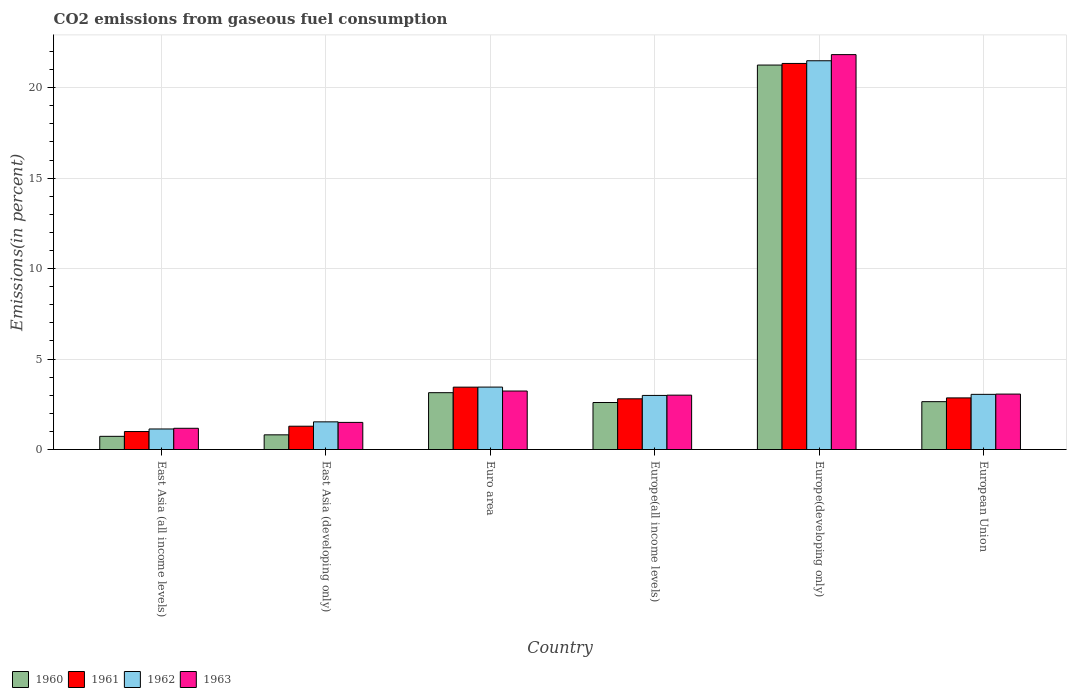Are the number of bars per tick equal to the number of legend labels?
Your response must be concise. Yes. Are the number of bars on each tick of the X-axis equal?
Give a very brief answer. Yes. How many bars are there on the 5th tick from the left?
Give a very brief answer. 4. What is the label of the 1st group of bars from the left?
Your response must be concise. East Asia (all income levels). What is the total CO2 emitted in 1960 in Euro area?
Keep it short and to the point. 3.14. Across all countries, what is the maximum total CO2 emitted in 1961?
Provide a short and direct response. 21.34. Across all countries, what is the minimum total CO2 emitted in 1963?
Make the answer very short. 1.17. In which country was the total CO2 emitted in 1961 maximum?
Keep it short and to the point. Europe(developing only). In which country was the total CO2 emitted in 1963 minimum?
Give a very brief answer. East Asia (all income levels). What is the total total CO2 emitted in 1961 in the graph?
Offer a very short reply. 32.73. What is the difference between the total CO2 emitted in 1961 in East Asia (all income levels) and that in Euro area?
Your answer should be compact. -2.45. What is the difference between the total CO2 emitted in 1961 in Europe(all income levels) and the total CO2 emitted in 1963 in Europe(developing only)?
Offer a very short reply. -19.03. What is the average total CO2 emitted in 1962 per country?
Your response must be concise. 5.61. What is the difference between the total CO2 emitted of/in 1960 and total CO2 emitted of/in 1963 in East Asia (all income levels)?
Ensure brevity in your answer.  -0.45. What is the ratio of the total CO2 emitted in 1961 in East Asia (all income levels) to that in European Union?
Give a very brief answer. 0.35. Is the difference between the total CO2 emitted in 1960 in East Asia (developing only) and Europe(developing only) greater than the difference between the total CO2 emitted in 1963 in East Asia (developing only) and Europe(developing only)?
Your answer should be very brief. No. What is the difference between the highest and the second highest total CO2 emitted in 1963?
Provide a short and direct response. -0.17. What is the difference between the highest and the lowest total CO2 emitted in 1962?
Your answer should be very brief. 20.35. Is the sum of the total CO2 emitted in 1963 in East Asia (all income levels) and Europe(developing only) greater than the maximum total CO2 emitted in 1962 across all countries?
Make the answer very short. Yes. What does the 4th bar from the right in Europe(developing only) represents?
Keep it short and to the point. 1960. Is it the case that in every country, the sum of the total CO2 emitted in 1960 and total CO2 emitted in 1962 is greater than the total CO2 emitted in 1963?
Your response must be concise. Yes. How many bars are there?
Give a very brief answer. 24. How many countries are there in the graph?
Give a very brief answer. 6. How are the legend labels stacked?
Your answer should be very brief. Horizontal. What is the title of the graph?
Offer a terse response. CO2 emissions from gaseous fuel consumption. Does "1975" appear as one of the legend labels in the graph?
Provide a succinct answer. No. What is the label or title of the X-axis?
Offer a terse response. Country. What is the label or title of the Y-axis?
Provide a short and direct response. Emissions(in percent). What is the Emissions(in percent) of 1960 in East Asia (all income levels)?
Offer a terse response. 0.73. What is the Emissions(in percent) in 1961 in East Asia (all income levels)?
Provide a short and direct response. 0.99. What is the Emissions(in percent) in 1962 in East Asia (all income levels)?
Your answer should be compact. 1.14. What is the Emissions(in percent) of 1963 in East Asia (all income levels)?
Ensure brevity in your answer.  1.17. What is the Emissions(in percent) in 1960 in East Asia (developing only)?
Keep it short and to the point. 0.81. What is the Emissions(in percent) of 1961 in East Asia (developing only)?
Keep it short and to the point. 1.29. What is the Emissions(in percent) in 1962 in East Asia (developing only)?
Offer a very short reply. 1.53. What is the Emissions(in percent) in 1963 in East Asia (developing only)?
Your answer should be very brief. 1.5. What is the Emissions(in percent) of 1960 in Euro area?
Your answer should be compact. 3.14. What is the Emissions(in percent) of 1961 in Euro area?
Your answer should be compact. 3.45. What is the Emissions(in percent) of 1962 in Euro area?
Offer a terse response. 3.45. What is the Emissions(in percent) in 1963 in Euro area?
Keep it short and to the point. 3.23. What is the Emissions(in percent) of 1960 in Europe(all income levels)?
Provide a succinct answer. 2.6. What is the Emissions(in percent) of 1961 in Europe(all income levels)?
Provide a short and direct response. 2.8. What is the Emissions(in percent) of 1962 in Europe(all income levels)?
Keep it short and to the point. 2.99. What is the Emissions(in percent) in 1963 in Europe(all income levels)?
Ensure brevity in your answer.  3.01. What is the Emissions(in percent) of 1960 in Europe(developing only)?
Your response must be concise. 21.25. What is the Emissions(in percent) in 1961 in Europe(developing only)?
Ensure brevity in your answer.  21.34. What is the Emissions(in percent) of 1962 in Europe(developing only)?
Ensure brevity in your answer.  21.49. What is the Emissions(in percent) of 1963 in Europe(developing only)?
Provide a short and direct response. 21.83. What is the Emissions(in percent) in 1960 in European Union?
Make the answer very short. 2.65. What is the Emissions(in percent) of 1961 in European Union?
Your answer should be very brief. 2.85. What is the Emissions(in percent) in 1962 in European Union?
Your response must be concise. 3.05. What is the Emissions(in percent) of 1963 in European Union?
Keep it short and to the point. 3.06. Across all countries, what is the maximum Emissions(in percent) of 1960?
Your answer should be very brief. 21.25. Across all countries, what is the maximum Emissions(in percent) in 1961?
Give a very brief answer. 21.34. Across all countries, what is the maximum Emissions(in percent) in 1962?
Ensure brevity in your answer.  21.49. Across all countries, what is the maximum Emissions(in percent) in 1963?
Offer a very short reply. 21.83. Across all countries, what is the minimum Emissions(in percent) of 1960?
Your answer should be compact. 0.73. Across all countries, what is the minimum Emissions(in percent) of 1961?
Your response must be concise. 0.99. Across all countries, what is the minimum Emissions(in percent) of 1962?
Your answer should be very brief. 1.14. Across all countries, what is the minimum Emissions(in percent) of 1963?
Your answer should be compact. 1.17. What is the total Emissions(in percent) of 1960 in the graph?
Offer a very short reply. 31.18. What is the total Emissions(in percent) of 1961 in the graph?
Make the answer very short. 32.73. What is the total Emissions(in percent) of 1962 in the graph?
Make the answer very short. 33.65. What is the total Emissions(in percent) of 1963 in the graph?
Your response must be concise. 33.81. What is the difference between the Emissions(in percent) in 1960 in East Asia (all income levels) and that in East Asia (developing only)?
Your answer should be compact. -0.08. What is the difference between the Emissions(in percent) of 1961 in East Asia (all income levels) and that in East Asia (developing only)?
Offer a very short reply. -0.29. What is the difference between the Emissions(in percent) in 1962 in East Asia (all income levels) and that in East Asia (developing only)?
Offer a terse response. -0.39. What is the difference between the Emissions(in percent) in 1963 in East Asia (all income levels) and that in East Asia (developing only)?
Keep it short and to the point. -0.33. What is the difference between the Emissions(in percent) in 1960 in East Asia (all income levels) and that in Euro area?
Your response must be concise. -2.41. What is the difference between the Emissions(in percent) in 1961 in East Asia (all income levels) and that in Euro area?
Provide a short and direct response. -2.45. What is the difference between the Emissions(in percent) in 1962 in East Asia (all income levels) and that in Euro area?
Provide a succinct answer. -2.32. What is the difference between the Emissions(in percent) of 1963 in East Asia (all income levels) and that in Euro area?
Keep it short and to the point. -2.06. What is the difference between the Emissions(in percent) in 1960 in East Asia (all income levels) and that in Europe(all income levels)?
Your response must be concise. -1.87. What is the difference between the Emissions(in percent) of 1961 in East Asia (all income levels) and that in Europe(all income levels)?
Make the answer very short. -1.81. What is the difference between the Emissions(in percent) of 1962 in East Asia (all income levels) and that in Europe(all income levels)?
Your answer should be very brief. -1.85. What is the difference between the Emissions(in percent) in 1963 in East Asia (all income levels) and that in Europe(all income levels)?
Provide a short and direct response. -1.83. What is the difference between the Emissions(in percent) of 1960 in East Asia (all income levels) and that in Europe(developing only)?
Make the answer very short. -20.52. What is the difference between the Emissions(in percent) of 1961 in East Asia (all income levels) and that in Europe(developing only)?
Your answer should be compact. -20.35. What is the difference between the Emissions(in percent) of 1962 in East Asia (all income levels) and that in Europe(developing only)?
Keep it short and to the point. -20.35. What is the difference between the Emissions(in percent) of 1963 in East Asia (all income levels) and that in Europe(developing only)?
Provide a succinct answer. -20.66. What is the difference between the Emissions(in percent) of 1960 in East Asia (all income levels) and that in European Union?
Give a very brief answer. -1.92. What is the difference between the Emissions(in percent) of 1961 in East Asia (all income levels) and that in European Union?
Ensure brevity in your answer.  -1.86. What is the difference between the Emissions(in percent) in 1962 in East Asia (all income levels) and that in European Union?
Your answer should be very brief. -1.91. What is the difference between the Emissions(in percent) in 1963 in East Asia (all income levels) and that in European Union?
Your response must be concise. -1.89. What is the difference between the Emissions(in percent) in 1960 in East Asia (developing only) and that in Euro area?
Offer a terse response. -2.33. What is the difference between the Emissions(in percent) of 1961 in East Asia (developing only) and that in Euro area?
Offer a very short reply. -2.16. What is the difference between the Emissions(in percent) in 1962 in East Asia (developing only) and that in Euro area?
Your response must be concise. -1.92. What is the difference between the Emissions(in percent) of 1963 in East Asia (developing only) and that in Euro area?
Keep it short and to the point. -1.73. What is the difference between the Emissions(in percent) of 1960 in East Asia (developing only) and that in Europe(all income levels)?
Your answer should be very brief. -1.79. What is the difference between the Emissions(in percent) in 1961 in East Asia (developing only) and that in Europe(all income levels)?
Offer a very short reply. -1.51. What is the difference between the Emissions(in percent) of 1962 in East Asia (developing only) and that in Europe(all income levels)?
Your answer should be compact. -1.46. What is the difference between the Emissions(in percent) in 1963 in East Asia (developing only) and that in Europe(all income levels)?
Ensure brevity in your answer.  -1.51. What is the difference between the Emissions(in percent) in 1960 in East Asia (developing only) and that in Europe(developing only)?
Offer a very short reply. -20.44. What is the difference between the Emissions(in percent) in 1961 in East Asia (developing only) and that in Europe(developing only)?
Make the answer very short. -20.05. What is the difference between the Emissions(in percent) of 1962 in East Asia (developing only) and that in Europe(developing only)?
Ensure brevity in your answer.  -19.96. What is the difference between the Emissions(in percent) of 1963 in East Asia (developing only) and that in Europe(developing only)?
Offer a very short reply. -20.33. What is the difference between the Emissions(in percent) of 1960 in East Asia (developing only) and that in European Union?
Provide a short and direct response. -1.83. What is the difference between the Emissions(in percent) of 1961 in East Asia (developing only) and that in European Union?
Provide a short and direct response. -1.56. What is the difference between the Emissions(in percent) in 1962 in East Asia (developing only) and that in European Union?
Ensure brevity in your answer.  -1.52. What is the difference between the Emissions(in percent) in 1963 in East Asia (developing only) and that in European Union?
Give a very brief answer. -1.57. What is the difference between the Emissions(in percent) in 1960 in Euro area and that in Europe(all income levels)?
Your answer should be compact. 0.54. What is the difference between the Emissions(in percent) of 1961 in Euro area and that in Europe(all income levels)?
Give a very brief answer. 0.64. What is the difference between the Emissions(in percent) of 1962 in Euro area and that in Europe(all income levels)?
Your answer should be compact. 0.46. What is the difference between the Emissions(in percent) of 1963 in Euro area and that in Europe(all income levels)?
Provide a succinct answer. 0.23. What is the difference between the Emissions(in percent) of 1960 in Euro area and that in Europe(developing only)?
Give a very brief answer. -18.11. What is the difference between the Emissions(in percent) in 1961 in Euro area and that in Europe(developing only)?
Ensure brevity in your answer.  -17.89. What is the difference between the Emissions(in percent) of 1962 in Euro area and that in Europe(developing only)?
Offer a terse response. -18.04. What is the difference between the Emissions(in percent) of 1963 in Euro area and that in Europe(developing only)?
Keep it short and to the point. -18.6. What is the difference between the Emissions(in percent) of 1960 in Euro area and that in European Union?
Make the answer very short. 0.5. What is the difference between the Emissions(in percent) of 1961 in Euro area and that in European Union?
Give a very brief answer. 0.59. What is the difference between the Emissions(in percent) of 1962 in Euro area and that in European Union?
Your answer should be very brief. 0.4. What is the difference between the Emissions(in percent) of 1963 in Euro area and that in European Union?
Give a very brief answer. 0.17. What is the difference between the Emissions(in percent) of 1960 in Europe(all income levels) and that in Europe(developing only)?
Provide a short and direct response. -18.65. What is the difference between the Emissions(in percent) in 1961 in Europe(all income levels) and that in Europe(developing only)?
Offer a very short reply. -18.54. What is the difference between the Emissions(in percent) in 1962 in Europe(all income levels) and that in Europe(developing only)?
Offer a terse response. -18.5. What is the difference between the Emissions(in percent) in 1963 in Europe(all income levels) and that in Europe(developing only)?
Make the answer very short. -18.82. What is the difference between the Emissions(in percent) of 1960 in Europe(all income levels) and that in European Union?
Offer a terse response. -0.05. What is the difference between the Emissions(in percent) of 1961 in Europe(all income levels) and that in European Union?
Your answer should be compact. -0.05. What is the difference between the Emissions(in percent) in 1962 in Europe(all income levels) and that in European Union?
Keep it short and to the point. -0.06. What is the difference between the Emissions(in percent) of 1963 in Europe(all income levels) and that in European Union?
Offer a terse response. -0.06. What is the difference between the Emissions(in percent) of 1960 in Europe(developing only) and that in European Union?
Provide a short and direct response. 18.61. What is the difference between the Emissions(in percent) in 1961 in Europe(developing only) and that in European Union?
Ensure brevity in your answer.  18.49. What is the difference between the Emissions(in percent) in 1962 in Europe(developing only) and that in European Union?
Your answer should be compact. 18.44. What is the difference between the Emissions(in percent) in 1963 in Europe(developing only) and that in European Union?
Keep it short and to the point. 18.76. What is the difference between the Emissions(in percent) in 1960 in East Asia (all income levels) and the Emissions(in percent) in 1961 in East Asia (developing only)?
Offer a very short reply. -0.56. What is the difference between the Emissions(in percent) in 1960 in East Asia (all income levels) and the Emissions(in percent) in 1962 in East Asia (developing only)?
Your answer should be compact. -0.8. What is the difference between the Emissions(in percent) of 1960 in East Asia (all income levels) and the Emissions(in percent) of 1963 in East Asia (developing only)?
Keep it short and to the point. -0.77. What is the difference between the Emissions(in percent) of 1961 in East Asia (all income levels) and the Emissions(in percent) of 1962 in East Asia (developing only)?
Give a very brief answer. -0.54. What is the difference between the Emissions(in percent) in 1961 in East Asia (all income levels) and the Emissions(in percent) in 1963 in East Asia (developing only)?
Offer a terse response. -0.51. What is the difference between the Emissions(in percent) in 1962 in East Asia (all income levels) and the Emissions(in percent) in 1963 in East Asia (developing only)?
Your answer should be very brief. -0.36. What is the difference between the Emissions(in percent) in 1960 in East Asia (all income levels) and the Emissions(in percent) in 1961 in Euro area?
Offer a very short reply. -2.72. What is the difference between the Emissions(in percent) of 1960 in East Asia (all income levels) and the Emissions(in percent) of 1962 in Euro area?
Offer a very short reply. -2.72. What is the difference between the Emissions(in percent) of 1960 in East Asia (all income levels) and the Emissions(in percent) of 1963 in Euro area?
Your response must be concise. -2.51. What is the difference between the Emissions(in percent) in 1961 in East Asia (all income levels) and the Emissions(in percent) in 1962 in Euro area?
Make the answer very short. -2.46. What is the difference between the Emissions(in percent) in 1961 in East Asia (all income levels) and the Emissions(in percent) in 1963 in Euro area?
Your answer should be very brief. -2.24. What is the difference between the Emissions(in percent) in 1962 in East Asia (all income levels) and the Emissions(in percent) in 1963 in Euro area?
Give a very brief answer. -2.1. What is the difference between the Emissions(in percent) in 1960 in East Asia (all income levels) and the Emissions(in percent) in 1961 in Europe(all income levels)?
Provide a succinct answer. -2.07. What is the difference between the Emissions(in percent) of 1960 in East Asia (all income levels) and the Emissions(in percent) of 1962 in Europe(all income levels)?
Offer a terse response. -2.26. What is the difference between the Emissions(in percent) in 1960 in East Asia (all income levels) and the Emissions(in percent) in 1963 in Europe(all income levels)?
Offer a very short reply. -2.28. What is the difference between the Emissions(in percent) of 1961 in East Asia (all income levels) and the Emissions(in percent) of 1962 in Europe(all income levels)?
Make the answer very short. -2. What is the difference between the Emissions(in percent) of 1961 in East Asia (all income levels) and the Emissions(in percent) of 1963 in Europe(all income levels)?
Your answer should be compact. -2.01. What is the difference between the Emissions(in percent) of 1962 in East Asia (all income levels) and the Emissions(in percent) of 1963 in Europe(all income levels)?
Provide a short and direct response. -1.87. What is the difference between the Emissions(in percent) of 1960 in East Asia (all income levels) and the Emissions(in percent) of 1961 in Europe(developing only)?
Keep it short and to the point. -20.61. What is the difference between the Emissions(in percent) in 1960 in East Asia (all income levels) and the Emissions(in percent) in 1962 in Europe(developing only)?
Your response must be concise. -20.76. What is the difference between the Emissions(in percent) of 1960 in East Asia (all income levels) and the Emissions(in percent) of 1963 in Europe(developing only)?
Keep it short and to the point. -21.1. What is the difference between the Emissions(in percent) of 1961 in East Asia (all income levels) and the Emissions(in percent) of 1962 in Europe(developing only)?
Offer a terse response. -20.5. What is the difference between the Emissions(in percent) in 1961 in East Asia (all income levels) and the Emissions(in percent) in 1963 in Europe(developing only)?
Your response must be concise. -20.84. What is the difference between the Emissions(in percent) in 1962 in East Asia (all income levels) and the Emissions(in percent) in 1963 in Europe(developing only)?
Provide a succinct answer. -20.69. What is the difference between the Emissions(in percent) of 1960 in East Asia (all income levels) and the Emissions(in percent) of 1961 in European Union?
Offer a terse response. -2.13. What is the difference between the Emissions(in percent) in 1960 in East Asia (all income levels) and the Emissions(in percent) in 1962 in European Union?
Your answer should be compact. -2.32. What is the difference between the Emissions(in percent) of 1960 in East Asia (all income levels) and the Emissions(in percent) of 1963 in European Union?
Ensure brevity in your answer.  -2.34. What is the difference between the Emissions(in percent) in 1961 in East Asia (all income levels) and the Emissions(in percent) in 1962 in European Union?
Keep it short and to the point. -2.06. What is the difference between the Emissions(in percent) in 1961 in East Asia (all income levels) and the Emissions(in percent) in 1963 in European Union?
Keep it short and to the point. -2.07. What is the difference between the Emissions(in percent) in 1962 in East Asia (all income levels) and the Emissions(in percent) in 1963 in European Union?
Provide a succinct answer. -1.93. What is the difference between the Emissions(in percent) in 1960 in East Asia (developing only) and the Emissions(in percent) in 1961 in Euro area?
Provide a short and direct response. -2.64. What is the difference between the Emissions(in percent) in 1960 in East Asia (developing only) and the Emissions(in percent) in 1962 in Euro area?
Offer a very short reply. -2.64. What is the difference between the Emissions(in percent) in 1960 in East Asia (developing only) and the Emissions(in percent) in 1963 in Euro area?
Provide a short and direct response. -2.42. What is the difference between the Emissions(in percent) in 1961 in East Asia (developing only) and the Emissions(in percent) in 1962 in Euro area?
Provide a short and direct response. -2.16. What is the difference between the Emissions(in percent) of 1961 in East Asia (developing only) and the Emissions(in percent) of 1963 in Euro area?
Your answer should be compact. -1.95. What is the difference between the Emissions(in percent) in 1962 in East Asia (developing only) and the Emissions(in percent) in 1963 in Euro area?
Keep it short and to the point. -1.7. What is the difference between the Emissions(in percent) in 1960 in East Asia (developing only) and the Emissions(in percent) in 1961 in Europe(all income levels)?
Offer a terse response. -1.99. What is the difference between the Emissions(in percent) of 1960 in East Asia (developing only) and the Emissions(in percent) of 1962 in Europe(all income levels)?
Offer a terse response. -2.18. What is the difference between the Emissions(in percent) in 1960 in East Asia (developing only) and the Emissions(in percent) in 1963 in Europe(all income levels)?
Offer a terse response. -2.19. What is the difference between the Emissions(in percent) of 1961 in East Asia (developing only) and the Emissions(in percent) of 1962 in Europe(all income levels)?
Your answer should be very brief. -1.7. What is the difference between the Emissions(in percent) in 1961 in East Asia (developing only) and the Emissions(in percent) in 1963 in Europe(all income levels)?
Provide a short and direct response. -1.72. What is the difference between the Emissions(in percent) in 1962 in East Asia (developing only) and the Emissions(in percent) in 1963 in Europe(all income levels)?
Your answer should be compact. -1.48. What is the difference between the Emissions(in percent) of 1960 in East Asia (developing only) and the Emissions(in percent) of 1961 in Europe(developing only)?
Your answer should be compact. -20.53. What is the difference between the Emissions(in percent) of 1960 in East Asia (developing only) and the Emissions(in percent) of 1962 in Europe(developing only)?
Give a very brief answer. -20.68. What is the difference between the Emissions(in percent) of 1960 in East Asia (developing only) and the Emissions(in percent) of 1963 in Europe(developing only)?
Provide a short and direct response. -21.02. What is the difference between the Emissions(in percent) of 1961 in East Asia (developing only) and the Emissions(in percent) of 1962 in Europe(developing only)?
Your answer should be compact. -20.2. What is the difference between the Emissions(in percent) of 1961 in East Asia (developing only) and the Emissions(in percent) of 1963 in Europe(developing only)?
Offer a very short reply. -20.54. What is the difference between the Emissions(in percent) of 1962 in East Asia (developing only) and the Emissions(in percent) of 1963 in Europe(developing only)?
Give a very brief answer. -20.3. What is the difference between the Emissions(in percent) in 1960 in East Asia (developing only) and the Emissions(in percent) in 1961 in European Union?
Your response must be concise. -2.04. What is the difference between the Emissions(in percent) in 1960 in East Asia (developing only) and the Emissions(in percent) in 1962 in European Union?
Keep it short and to the point. -2.24. What is the difference between the Emissions(in percent) of 1960 in East Asia (developing only) and the Emissions(in percent) of 1963 in European Union?
Your response must be concise. -2.25. What is the difference between the Emissions(in percent) in 1961 in East Asia (developing only) and the Emissions(in percent) in 1962 in European Union?
Offer a very short reply. -1.76. What is the difference between the Emissions(in percent) of 1961 in East Asia (developing only) and the Emissions(in percent) of 1963 in European Union?
Keep it short and to the point. -1.78. What is the difference between the Emissions(in percent) in 1962 in East Asia (developing only) and the Emissions(in percent) in 1963 in European Union?
Provide a short and direct response. -1.54. What is the difference between the Emissions(in percent) of 1960 in Euro area and the Emissions(in percent) of 1961 in Europe(all income levels)?
Keep it short and to the point. 0.34. What is the difference between the Emissions(in percent) in 1960 in Euro area and the Emissions(in percent) in 1962 in Europe(all income levels)?
Make the answer very short. 0.15. What is the difference between the Emissions(in percent) in 1960 in Euro area and the Emissions(in percent) in 1963 in Europe(all income levels)?
Provide a succinct answer. 0.14. What is the difference between the Emissions(in percent) in 1961 in Euro area and the Emissions(in percent) in 1962 in Europe(all income levels)?
Make the answer very short. 0.46. What is the difference between the Emissions(in percent) in 1961 in Euro area and the Emissions(in percent) in 1963 in Europe(all income levels)?
Provide a succinct answer. 0.44. What is the difference between the Emissions(in percent) of 1962 in Euro area and the Emissions(in percent) of 1963 in Europe(all income levels)?
Offer a terse response. 0.45. What is the difference between the Emissions(in percent) of 1960 in Euro area and the Emissions(in percent) of 1961 in Europe(developing only)?
Offer a very short reply. -18.2. What is the difference between the Emissions(in percent) in 1960 in Euro area and the Emissions(in percent) in 1962 in Europe(developing only)?
Provide a succinct answer. -18.35. What is the difference between the Emissions(in percent) of 1960 in Euro area and the Emissions(in percent) of 1963 in Europe(developing only)?
Offer a very short reply. -18.69. What is the difference between the Emissions(in percent) in 1961 in Euro area and the Emissions(in percent) in 1962 in Europe(developing only)?
Make the answer very short. -18.04. What is the difference between the Emissions(in percent) in 1961 in Euro area and the Emissions(in percent) in 1963 in Europe(developing only)?
Give a very brief answer. -18.38. What is the difference between the Emissions(in percent) in 1962 in Euro area and the Emissions(in percent) in 1963 in Europe(developing only)?
Offer a very short reply. -18.38. What is the difference between the Emissions(in percent) in 1960 in Euro area and the Emissions(in percent) in 1961 in European Union?
Offer a very short reply. 0.29. What is the difference between the Emissions(in percent) of 1960 in Euro area and the Emissions(in percent) of 1962 in European Union?
Provide a short and direct response. 0.09. What is the difference between the Emissions(in percent) in 1960 in Euro area and the Emissions(in percent) in 1963 in European Union?
Provide a short and direct response. 0.08. What is the difference between the Emissions(in percent) in 1961 in Euro area and the Emissions(in percent) in 1962 in European Union?
Your answer should be compact. 0.4. What is the difference between the Emissions(in percent) in 1961 in Euro area and the Emissions(in percent) in 1963 in European Union?
Your answer should be compact. 0.38. What is the difference between the Emissions(in percent) in 1962 in Euro area and the Emissions(in percent) in 1963 in European Union?
Keep it short and to the point. 0.39. What is the difference between the Emissions(in percent) of 1960 in Europe(all income levels) and the Emissions(in percent) of 1961 in Europe(developing only)?
Keep it short and to the point. -18.74. What is the difference between the Emissions(in percent) of 1960 in Europe(all income levels) and the Emissions(in percent) of 1962 in Europe(developing only)?
Make the answer very short. -18.89. What is the difference between the Emissions(in percent) of 1960 in Europe(all income levels) and the Emissions(in percent) of 1963 in Europe(developing only)?
Your answer should be very brief. -19.23. What is the difference between the Emissions(in percent) in 1961 in Europe(all income levels) and the Emissions(in percent) in 1962 in Europe(developing only)?
Offer a very short reply. -18.69. What is the difference between the Emissions(in percent) of 1961 in Europe(all income levels) and the Emissions(in percent) of 1963 in Europe(developing only)?
Ensure brevity in your answer.  -19.03. What is the difference between the Emissions(in percent) of 1962 in Europe(all income levels) and the Emissions(in percent) of 1963 in Europe(developing only)?
Your answer should be compact. -18.84. What is the difference between the Emissions(in percent) of 1960 in Europe(all income levels) and the Emissions(in percent) of 1961 in European Union?
Keep it short and to the point. -0.25. What is the difference between the Emissions(in percent) in 1960 in Europe(all income levels) and the Emissions(in percent) in 1962 in European Union?
Your answer should be compact. -0.45. What is the difference between the Emissions(in percent) of 1960 in Europe(all income levels) and the Emissions(in percent) of 1963 in European Union?
Provide a short and direct response. -0.47. What is the difference between the Emissions(in percent) of 1961 in Europe(all income levels) and the Emissions(in percent) of 1962 in European Union?
Ensure brevity in your answer.  -0.25. What is the difference between the Emissions(in percent) in 1961 in Europe(all income levels) and the Emissions(in percent) in 1963 in European Union?
Offer a very short reply. -0.26. What is the difference between the Emissions(in percent) of 1962 in Europe(all income levels) and the Emissions(in percent) of 1963 in European Union?
Ensure brevity in your answer.  -0.07. What is the difference between the Emissions(in percent) in 1960 in Europe(developing only) and the Emissions(in percent) in 1961 in European Union?
Make the answer very short. 18.4. What is the difference between the Emissions(in percent) of 1960 in Europe(developing only) and the Emissions(in percent) of 1962 in European Union?
Give a very brief answer. 18.2. What is the difference between the Emissions(in percent) in 1960 in Europe(developing only) and the Emissions(in percent) in 1963 in European Union?
Your answer should be very brief. 18.19. What is the difference between the Emissions(in percent) in 1961 in Europe(developing only) and the Emissions(in percent) in 1962 in European Union?
Your response must be concise. 18.29. What is the difference between the Emissions(in percent) of 1961 in Europe(developing only) and the Emissions(in percent) of 1963 in European Union?
Your response must be concise. 18.28. What is the difference between the Emissions(in percent) in 1962 in Europe(developing only) and the Emissions(in percent) in 1963 in European Union?
Your response must be concise. 18.43. What is the average Emissions(in percent) of 1960 per country?
Your response must be concise. 5.2. What is the average Emissions(in percent) of 1961 per country?
Ensure brevity in your answer.  5.45. What is the average Emissions(in percent) of 1962 per country?
Make the answer very short. 5.61. What is the average Emissions(in percent) of 1963 per country?
Offer a terse response. 5.63. What is the difference between the Emissions(in percent) in 1960 and Emissions(in percent) in 1961 in East Asia (all income levels)?
Offer a terse response. -0.27. What is the difference between the Emissions(in percent) of 1960 and Emissions(in percent) of 1962 in East Asia (all income levels)?
Provide a succinct answer. -0.41. What is the difference between the Emissions(in percent) of 1960 and Emissions(in percent) of 1963 in East Asia (all income levels)?
Offer a terse response. -0.45. What is the difference between the Emissions(in percent) in 1961 and Emissions(in percent) in 1962 in East Asia (all income levels)?
Your response must be concise. -0.14. What is the difference between the Emissions(in percent) in 1961 and Emissions(in percent) in 1963 in East Asia (all income levels)?
Your answer should be very brief. -0.18. What is the difference between the Emissions(in percent) in 1962 and Emissions(in percent) in 1963 in East Asia (all income levels)?
Your response must be concise. -0.04. What is the difference between the Emissions(in percent) in 1960 and Emissions(in percent) in 1961 in East Asia (developing only)?
Provide a short and direct response. -0.48. What is the difference between the Emissions(in percent) in 1960 and Emissions(in percent) in 1962 in East Asia (developing only)?
Your answer should be compact. -0.72. What is the difference between the Emissions(in percent) of 1960 and Emissions(in percent) of 1963 in East Asia (developing only)?
Your answer should be compact. -0.69. What is the difference between the Emissions(in percent) of 1961 and Emissions(in percent) of 1962 in East Asia (developing only)?
Offer a terse response. -0.24. What is the difference between the Emissions(in percent) in 1961 and Emissions(in percent) in 1963 in East Asia (developing only)?
Make the answer very short. -0.21. What is the difference between the Emissions(in percent) of 1962 and Emissions(in percent) of 1963 in East Asia (developing only)?
Keep it short and to the point. 0.03. What is the difference between the Emissions(in percent) of 1960 and Emissions(in percent) of 1961 in Euro area?
Keep it short and to the point. -0.3. What is the difference between the Emissions(in percent) in 1960 and Emissions(in percent) in 1962 in Euro area?
Ensure brevity in your answer.  -0.31. What is the difference between the Emissions(in percent) of 1960 and Emissions(in percent) of 1963 in Euro area?
Offer a terse response. -0.09. What is the difference between the Emissions(in percent) of 1961 and Emissions(in percent) of 1962 in Euro area?
Provide a succinct answer. -0. What is the difference between the Emissions(in percent) in 1961 and Emissions(in percent) in 1963 in Euro area?
Your response must be concise. 0.21. What is the difference between the Emissions(in percent) of 1962 and Emissions(in percent) of 1963 in Euro area?
Ensure brevity in your answer.  0.22. What is the difference between the Emissions(in percent) of 1960 and Emissions(in percent) of 1961 in Europe(all income levels)?
Your answer should be very brief. -0.2. What is the difference between the Emissions(in percent) in 1960 and Emissions(in percent) in 1962 in Europe(all income levels)?
Your answer should be compact. -0.39. What is the difference between the Emissions(in percent) of 1960 and Emissions(in percent) of 1963 in Europe(all income levels)?
Give a very brief answer. -0.41. What is the difference between the Emissions(in percent) of 1961 and Emissions(in percent) of 1962 in Europe(all income levels)?
Provide a succinct answer. -0.19. What is the difference between the Emissions(in percent) in 1961 and Emissions(in percent) in 1963 in Europe(all income levels)?
Provide a short and direct response. -0.2. What is the difference between the Emissions(in percent) in 1962 and Emissions(in percent) in 1963 in Europe(all income levels)?
Your answer should be compact. -0.02. What is the difference between the Emissions(in percent) in 1960 and Emissions(in percent) in 1961 in Europe(developing only)?
Offer a very short reply. -0.09. What is the difference between the Emissions(in percent) in 1960 and Emissions(in percent) in 1962 in Europe(developing only)?
Offer a very short reply. -0.24. What is the difference between the Emissions(in percent) in 1960 and Emissions(in percent) in 1963 in Europe(developing only)?
Offer a terse response. -0.58. What is the difference between the Emissions(in percent) in 1961 and Emissions(in percent) in 1962 in Europe(developing only)?
Your response must be concise. -0.15. What is the difference between the Emissions(in percent) of 1961 and Emissions(in percent) of 1963 in Europe(developing only)?
Provide a succinct answer. -0.49. What is the difference between the Emissions(in percent) of 1962 and Emissions(in percent) of 1963 in Europe(developing only)?
Ensure brevity in your answer.  -0.34. What is the difference between the Emissions(in percent) of 1960 and Emissions(in percent) of 1961 in European Union?
Ensure brevity in your answer.  -0.21. What is the difference between the Emissions(in percent) in 1960 and Emissions(in percent) in 1962 in European Union?
Keep it short and to the point. -0.4. What is the difference between the Emissions(in percent) in 1960 and Emissions(in percent) in 1963 in European Union?
Provide a succinct answer. -0.42. What is the difference between the Emissions(in percent) in 1961 and Emissions(in percent) in 1962 in European Union?
Give a very brief answer. -0.2. What is the difference between the Emissions(in percent) in 1961 and Emissions(in percent) in 1963 in European Union?
Keep it short and to the point. -0.21. What is the difference between the Emissions(in percent) in 1962 and Emissions(in percent) in 1963 in European Union?
Provide a short and direct response. -0.01. What is the ratio of the Emissions(in percent) of 1960 in East Asia (all income levels) to that in East Asia (developing only)?
Your answer should be very brief. 0.9. What is the ratio of the Emissions(in percent) of 1961 in East Asia (all income levels) to that in East Asia (developing only)?
Make the answer very short. 0.77. What is the ratio of the Emissions(in percent) of 1962 in East Asia (all income levels) to that in East Asia (developing only)?
Your answer should be compact. 0.74. What is the ratio of the Emissions(in percent) in 1963 in East Asia (all income levels) to that in East Asia (developing only)?
Your answer should be very brief. 0.78. What is the ratio of the Emissions(in percent) in 1960 in East Asia (all income levels) to that in Euro area?
Provide a succinct answer. 0.23. What is the ratio of the Emissions(in percent) in 1961 in East Asia (all income levels) to that in Euro area?
Give a very brief answer. 0.29. What is the ratio of the Emissions(in percent) of 1962 in East Asia (all income levels) to that in Euro area?
Ensure brevity in your answer.  0.33. What is the ratio of the Emissions(in percent) of 1963 in East Asia (all income levels) to that in Euro area?
Offer a terse response. 0.36. What is the ratio of the Emissions(in percent) in 1960 in East Asia (all income levels) to that in Europe(all income levels)?
Your response must be concise. 0.28. What is the ratio of the Emissions(in percent) of 1961 in East Asia (all income levels) to that in Europe(all income levels)?
Your response must be concise. 0.35. What is the ratio of the Emissions(in percent) in 1962 in East Asia (all income levels) to that in Europe(all income levels)?
Make the answer very short. 0.38. What is the ratio of the Emissions(in percent) of 1963 in East Asia (all income levels) to that in Europe(all income levels)?
Ensure brevity in your answer.  0.39. What is the ratio of the Emissions(in percent) in 1960 in East Asia (all income levels) to that in Europe(developing only)?
Make the answer very short. 0.03. What is the ratio of the Emissions(in percent) in 1961 in East Asia (all income levels) to that in Europe(developing only)?
Offer a terse response. 0.05. What is the ratio of the Emissions(in percent) of 1962 in East Asia (all income levels) to that in Europe(developing only)?
Offer a very short reply. 0.05. What is the ratio of the Emissions(in percent) in 1963 in East Asia (all income levels) to that in Europe(developing only)?
Ensure brevity in your answer.  0.05. What is the ratio of the Emissions(in percent) of 1960 in East Asia (all income levels) to that in European Union?
Ensure brevity in your answer.  0.28. What is the ratio of the Emissions(in percent) in 1961 in East Asia (all income levels) to that in European Union?
Provide a succinct answer. 0.35. What is the ratio of the Emissions(in percent) of 1962 in East Asia (all income levels) to that in European Union?
Offer a very short reply. 0.37. What is the ratio of the Emissions(in percent) of 1963 in East Asia (all income levels) to that in European Union?
Offer a terse response. 0.38. What is the ratio of the Emissions(in percent) in 1960 in East Asia (developing only) to that in Euro area?
Give a very brief answer. 0.26. What is the ratio of the Emissions(in percent) of 1961 in East Asia (developing only) to that in Euro area?
Your answer should be compact. 0.37. What is the ratio of the Emissions(in percent) in 1962 in East Asia (developing only) to that in Euro area?
Give a very brief answer. 0.44. What is the ratio of the Emissions(in percent) in 1963 in East Asia (developing only) to that in Euro area?
Make the answer very short. 0.46. What is the ratio of the Emissions(in percent) in 1960 in East Asia (developing only) to that in Europe(all income levels)?
Give a very brief answer. 0.31. What is the ratio of the Emissions(in percent) in 1961 in East Asia (developing only) to that in Europe(all income levels)?
Keep it short and to the point. 0.46. What is the ratio of the Emissions(in percent) in 1962 in East Asia (developing only) to that in Europe(all income levels)?
Make the answer very short. 0.51. What is the ratio of the Emissions(in percent) of 1963 in East Asia (developing only) to that in Europe(all income levels)?
Provide a short and direct response. 0.5. What is the ratio of the Emissions(in percent) of 1960 in East Asia (developing only) to that in Europe(developing only)?
Your response must be concise. 0.04. What is the ratio of the Emissions(in percent) in 1961 in East Asia (developing only) to that in Europe(developing only)?
Your answer should be compact. 0.06. What is the ratio of the Emissions(in percent) in 1962 in East Asia (developing only) to that in Europe(developing only)?
Ensure brevity in your answer.  0.07. What is the ratio of the Emissions(in percent) in 1963 in East Asia (developing only) to that in Europe(developing only)?
Provide a succinct answer. 0.07. What is the ratio of the Emissions(in percent) of 1960 in East Asia (developing only) to that in European Union?
Give a very brief answer. 0.31. What is the ratio of the Emissions(in percent) of 1961 in East Asia (developing only) to that in European Union?
Your answer should be compact. 0.45. What is the ratio of the Emissions(in percent) in 1962 in East Asia (developing only) to that in European Union?
Offer a very short reply. 0.5. What is the ratio of the Emissions(in percent) in 1963 in East Asia (developing only) to that in European Union?
Your answer should be very brief. 0.49. What is the ratio of the Emissions(in percent) in 1960 in Euro area to that in Europe(all income levels)?
Provide a short and direct response. 1.21. What is the ratio of the Emissions(in percent) in 1961 in Euro area to that in Europe(all income levels)?
Your response must be concise. 1.23. What is the ratio of the Emissions(in percent) of 1962 in Euro area to that in Europe(all income levels)?
Keep it short and to the point. 1.15. What is the ratio of the Emissions(in percent) in 1963 in Euro area to that in Europe(all income levels)?
Offer a very short reply. 1.08. What is the ratio of the Emissions(in percent) of 1960 in Euro area to that in Europe(developing only)?
Give a very brief answer. 0.15. What is the ratio of the Emissions(in percent) in 1961 in Euro area to that in Europe(developing only)?
Provide a succinct answer. 0.16. What is the ratio of the Emissions(in percent) of 1962 in Euro area to that in Europe(developing only)?
Offer a terse response. 0.16. What is the ratio of the Emissions(in percent) of 1963 in Euro area to that in Europe(developing only)?
Your answer should be compact. 0.15. What is the ratio of the Emissions(in percent) of 1960 in Euro area to that in European Union?
Offer a terse response. 1.19. What is the ratio of the Emissions(in percent) of 1961 in Euro area to that in European Union?
Offer a terse response. 1.21. What is the ratio of the Emissions(in percent) in 1962 in Euro area to that in European Union?
Keep it short and to the point. 1.13. What is the ratio of the Emissions(in percent) of 1963 in Euro area to that in European Union?
Your answer should be very brief. 1.06. What is the ratio of the Emissions(in percent) of 1960 in Europe(all income levels) to that in Europe(developing only)?
Provide a short and direct response. 0.12. What is the ratio of the Emissions(in percent) in 1961 in Europe(all income levels) to that in Europe(developing only)?
Your answer should be very brief. 0.13. What is the ratio of the Emissions(in percent) in 1962 in Europe(all income levels) to that in Europe(developing only)?
Your response must be concise. 0.14. What is the ratio of the Emissions(in percent) of 1963 in Europe(all income levels) to that in Europe(developing only)?
Ensure brevity in your answer.  0.14. What is the ratio of the Emissions(in percent) in 1960 in Europe(all income levels) to that in European Union?
Provide a succinct answer. 0.98. What is the ratio of the Emissions(in percent) in 1961 in Europe(all income levels) to that in European Union?
Give a very brief answer. 0.98. What is the ratio of the Emissions(in percent) of 1962 in Europe(all income levels) to that in European Union?
Your answer should be very brief. 0.98. What is the ratio of the Emissions(in percent) in 1963 in Europe(all income levels) to that in European Union?
Offer a terse response. 0.98. What is the ratio of the Emissions(in percent) of 1960 in Europe(developing only) to that in European Union?
Ensure brevity in your answer.  8.03. What is the ratio of the Emissions(in percent) in 1961 in Europe(developing only) to that in European Union?
Offer a very short reply. 7.48. What is the ratio of the Emissions(in percent) in 1962 in Europe(developing only) to that in European Union?
Your answer should be compact. 7.05. What is the ratio of the Emissions(in percent) of 1963 in Europe(developing only) to that in European Union?
Ensure brevity in your answer.  7.12. What is the difference between the highest and the second highest Emissions(in percent) of 1960?
Offer a very short reply. 18.11. What is the difference between the highest and the second highest Emissions(in percent) of 1961?
Provide a succinct answer. 17.89. What is the difference between the highest and the second highest Emissions(in percent) in 1962?
Provide a succinct answer. 18.04. What is the difference between the highest and the second highest Emissions(in percent) in 1963?
Provide a short and direct response. 18.6. What is the difference between the highest and the lowest Emissions(in percent) of 1960?
Keep it short and to the point. 20.52. What is the difference between the highest and the lowest Emissions(in percent) of 1961?
Your answer should be very brief. 20.35. What is the difference between the highest and the lowest Emissions(in percent) in 1962?
Provide a succinct answer. 20.35. What is the difference between the highest and the lowest Emissions(in percent) in 1963?
Provide a succinct answer. 20.66. 